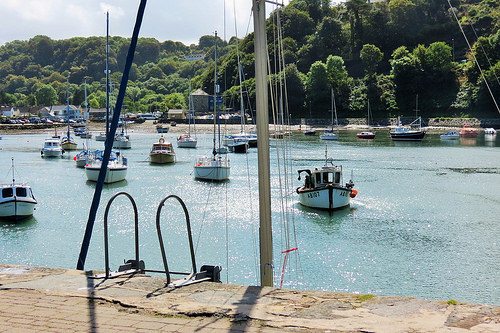<image>
Is the tree above the ship? No. The tree is not positioned above the ship. The vertical arrangement shows a different relationship. Is there a tree above the ship? No. The tree is not positioned above the ship. The vertical arrangement shows a different relationship. 